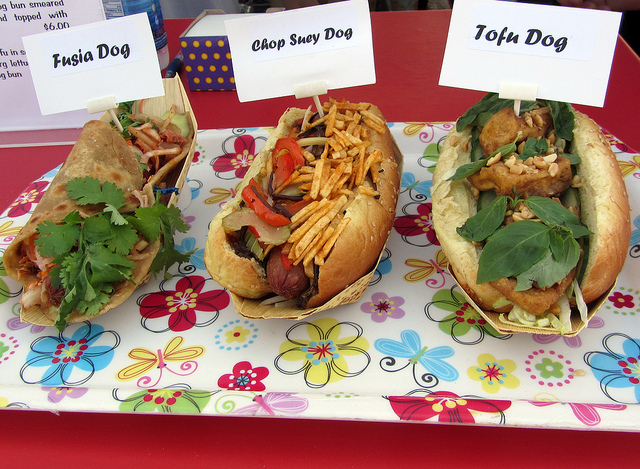<image>What is on the chop suey dog? I am not sure what is on the chop suey dog. It might be fries and vegetables, jalapenos, or hot dog with chop suey. What is on the chop suey dog? I don't know what is on the chop suey dog. It can be seen 'french fries and vegetables', 'fries peppers', 'carrot onion crispy noodle', 'celery peppers onion shoe sticks', or 'fries and vegetables'. 